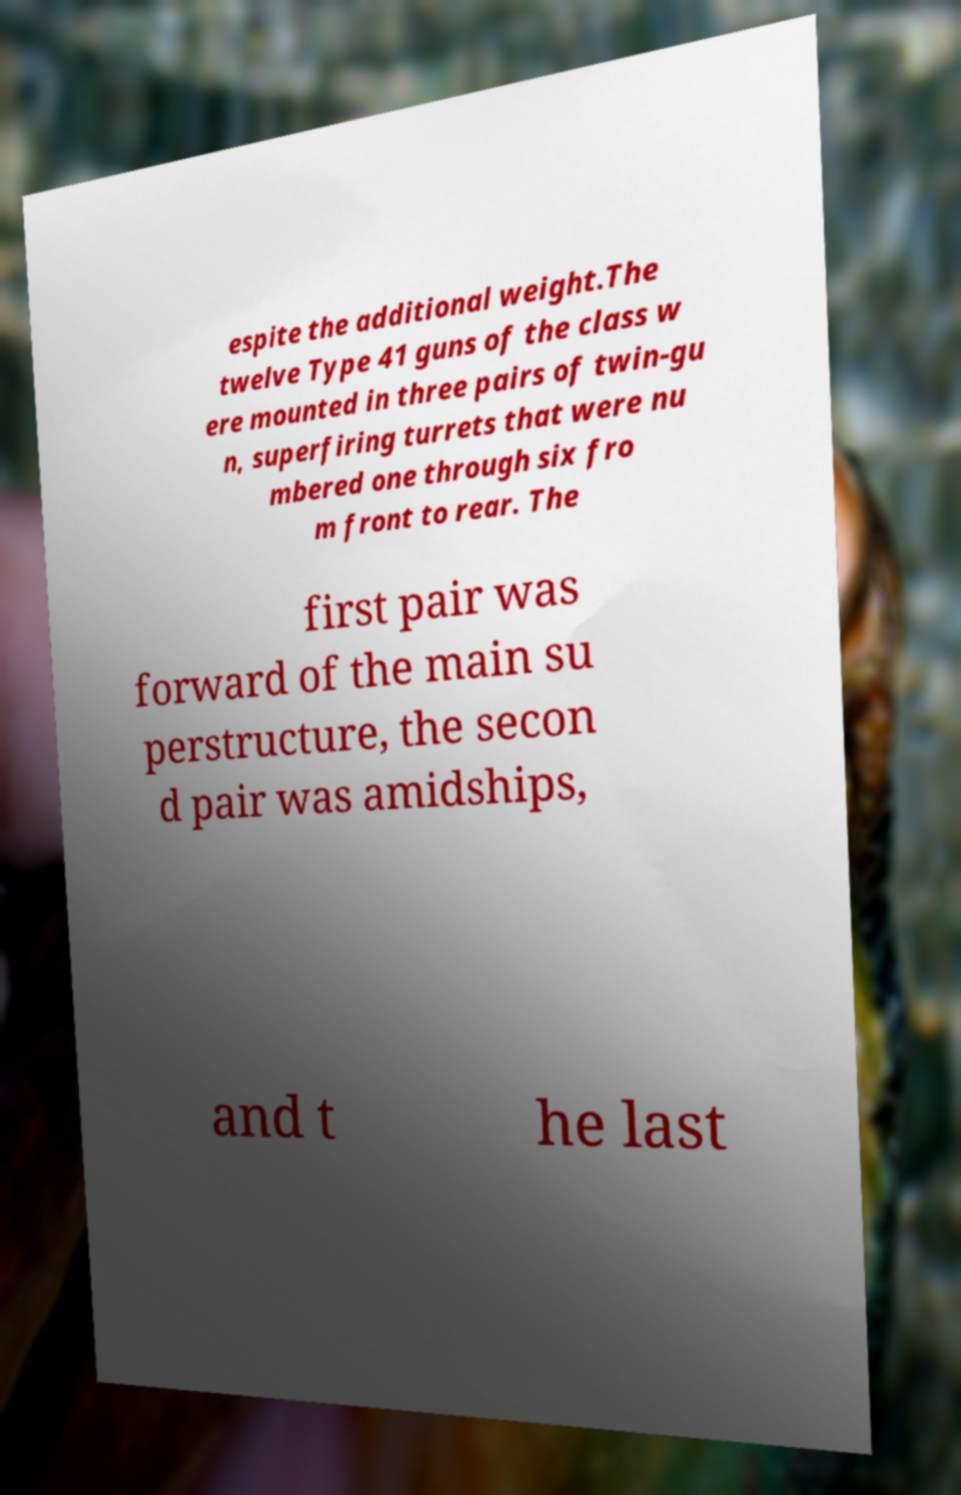Please read and relay the text visible in this image. What does it say? espite the additional weight.The twelve Type 41 guns of the class w ere mounted in three pairs of twin-gu n, superfiring turrets that were nu mbered one through six fro m front to rear. The first pair was forward of the main su perstructure, the secon d pair was amidships, and t he last 